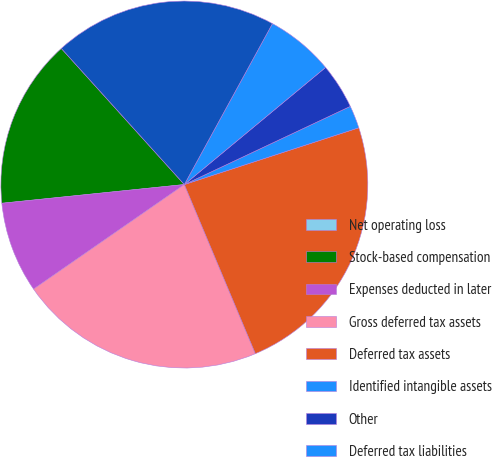Convert chart. <chart><loc_0><loc_0><loc_500><loc_500><pie_chart><fcel>Net operating loss<fcel>Stock-based compensation<fcel>Expenses deducted in later<fcel>Gross deferred tax assets<fcel>Deferred tax assets<fcel>Identified intangible assets<fcel>Other<fcel>Deferred tax liabilities<fcel>Net deferred tax assets<nl><fcel>0.0%<fcel>14.93%<fcel>8.02%<fcel>21.68%<fcel>23.68%<fcel>2.0%<fcel>4.01%<fcel>6.01%<fcel>19.67%<nl></chart> 